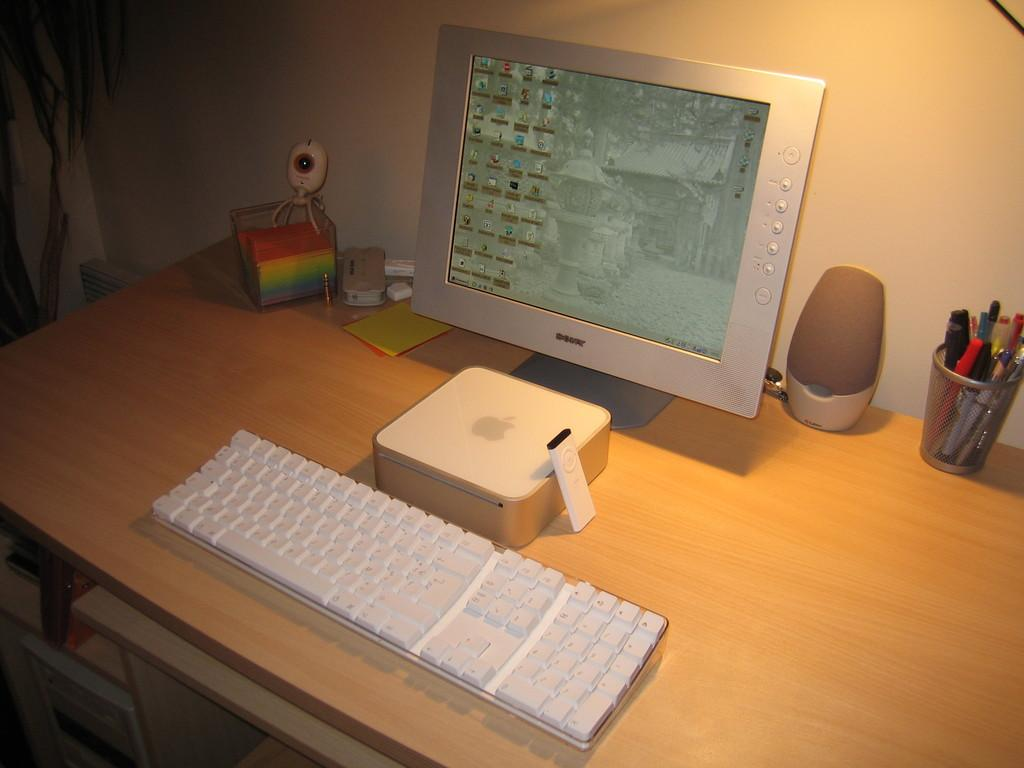What electronic device is on the table in the image? There is a monitor on the table in the image. What other device is on the table that is used for input? There is a keyboard on the table. What device is on the table that can be used for controlling other devices? There is a remote on the table. What device is on the table that can produce sound? There is a speaker on the table. What stationery item is on the table? There is a pen stand with pens on the table. What other unspecified objects are on the table? There are other unspecified objects on the table. Can you see a train passing over a bridge in the image? No, there is no train or bridge present in the image. Is there a plant growing on the table in the image? No, there is no plant visible on the table in the image. 